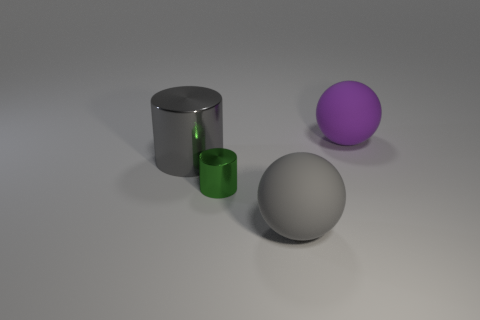Is the shape of the gray thing that is in front of the large metallic thing the same as the tiny shiny thing that is to the left of the purple rubber object?
Provide a succinct answer. No. How many tiny things are either gray metal cylinders or matte cylinders?
Provide a short and direct response. 0. The gray object that is the same material as the green cylinder is what shape?
Provide a short and direct response. Cylinder. Does the gray rubber object have the same shape as the purple object?
Your response must be concise. Yes. The tiny metal object has what color?
Your response must be concise. Green. What number of things are small cylinders or large purple things?
Provide a short and direct response. 2. Is there anything else that is the same material as the purple thing?
Your response must be concise. Yes. Are there fewer purple rubber balls in front of the big purple matte object than yellow metal balls?
Make the answer very short. No. Is the number of small metallic things right of the tiny cylinder greater than the number of large matte things that are to the left of the large shiny cylinder?
Your response must be concise. No. Is there anything else that is the same color as the large metallic object?
Provide a succinct answer. Yes. 